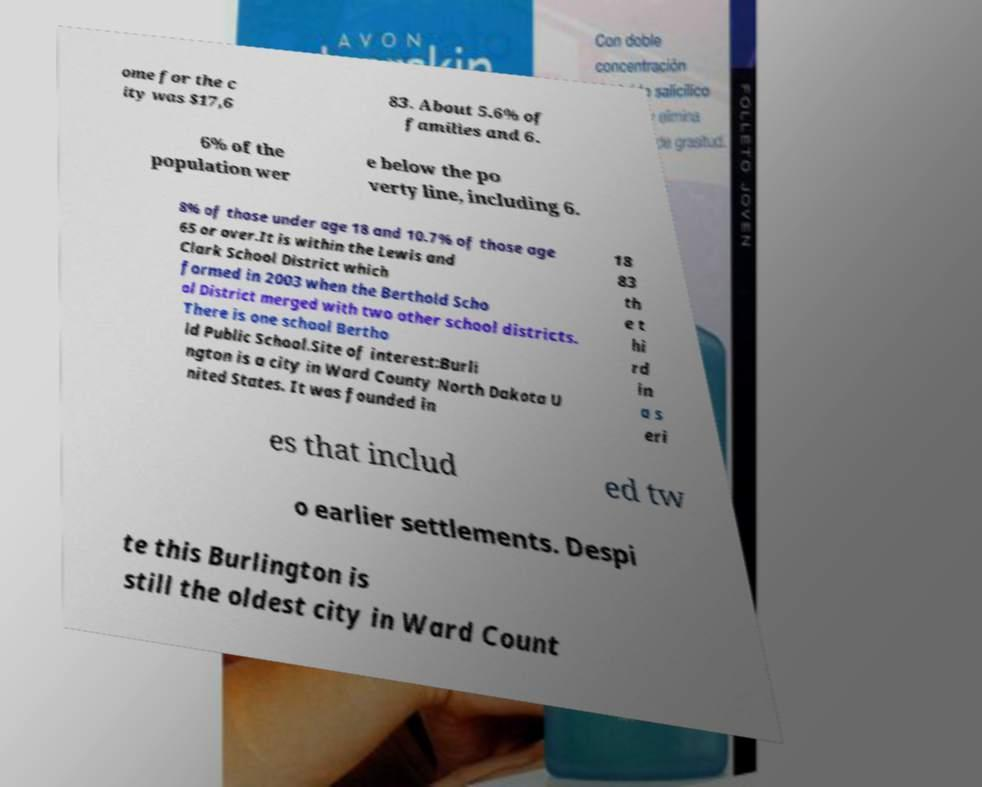What messages or text are displayed in this image? I need them in a readable, typed format. ome for the c ity was $17,6 83. About 5.6% of families and 6. 6% of the population wer e below the po verty line, including 6. 8% of those under age 18 and 10.7% of those age 65 or over.It is within the Lewis and Clark School District which formed in 2003 when the Berthold Scho ol District merged with two other school districts. There is one school Bertho ld Public School.Site of interest:Burli ngton is a city in Ward County North Dakota U nited States. It was founded in 18 83 th e t hi rd in a s eri es that includ ed tw o earlier settlements. Despi te this Burlington is still the oldest city in Ward Count 